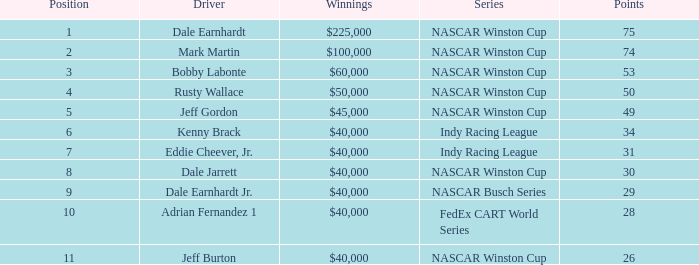In what position was the driver who won $60,000? 3.0. 